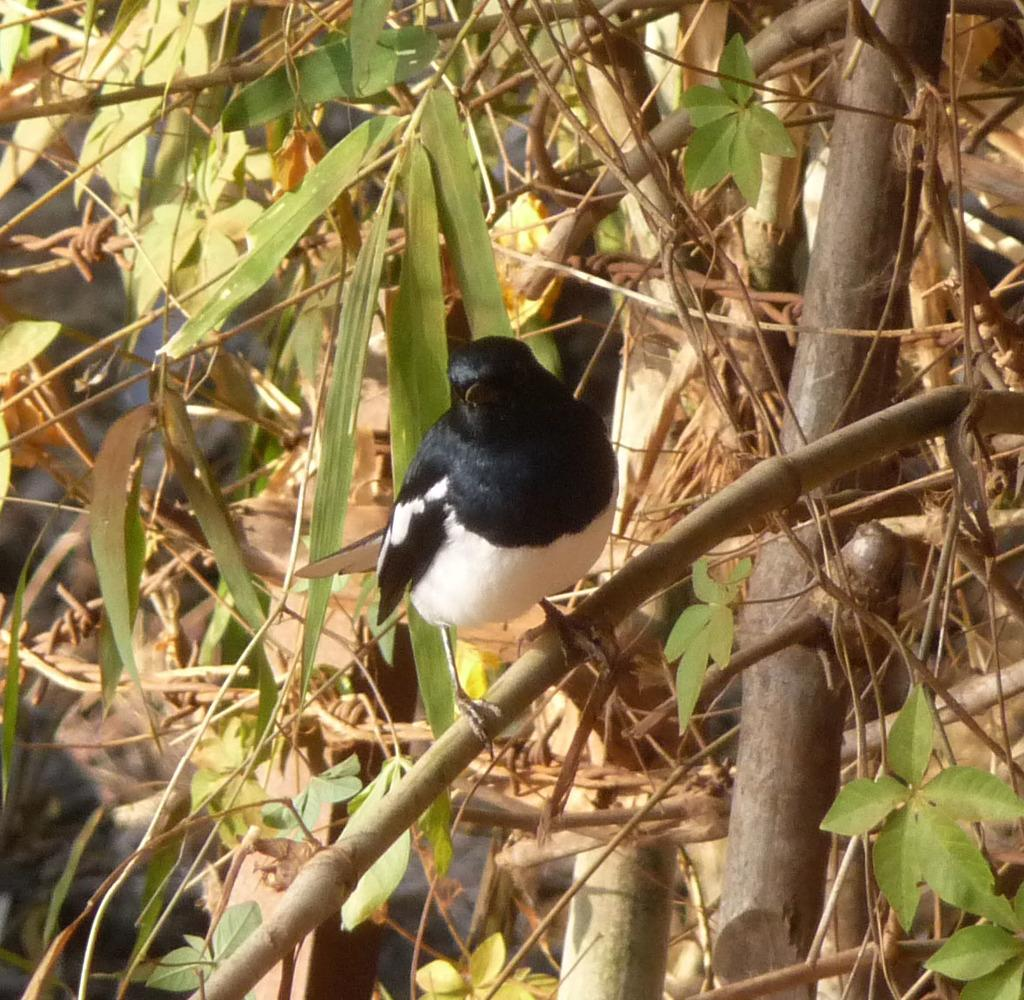What type of animal can be seen in the image? There is a bird in the image. Where is the bird located? The bird is on a plant. What is the color scheme of the image? The image is in black and white. What type of vegetation is present in the image? There are green leaves and stems in the image. What shape is the bird's nose in the image? There is no reference to a bird's nose in the image, as birds do not have noses. 